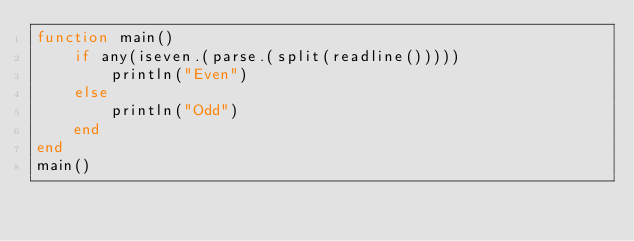Convert code to text. <code><loc_0><loc_0><loc_500><loc_500><_Julia_>function main()
    if any(iseven.(parse.(split(readline()))))
        println("Even")
    else
        println("Odd")
    end
end
main()</code> 